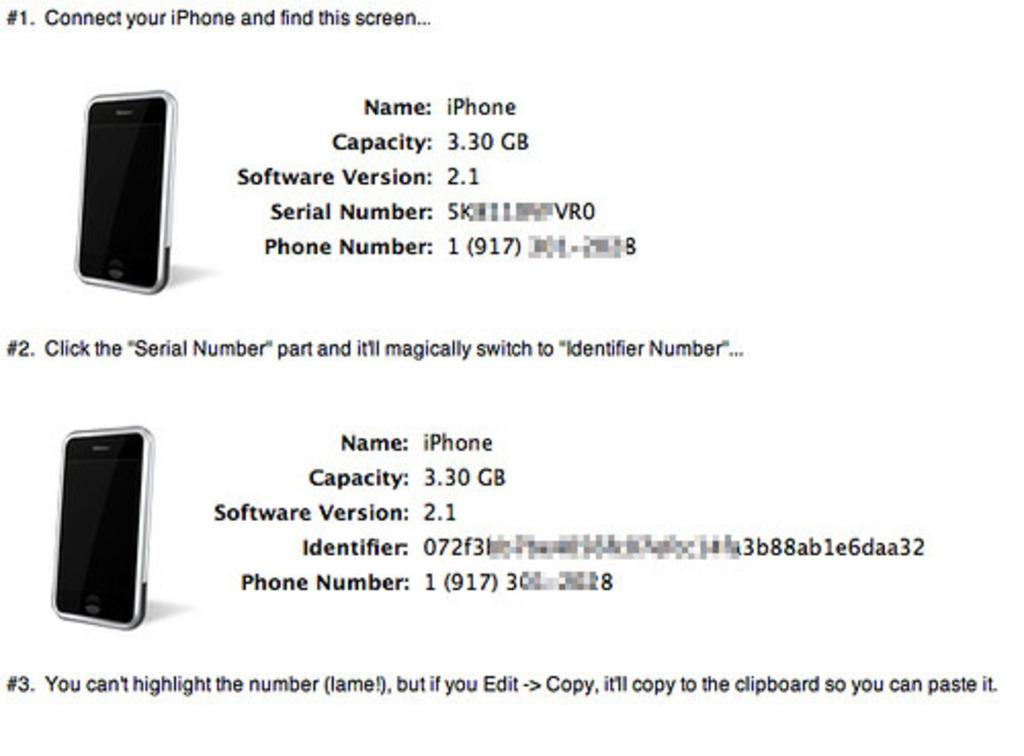Provide a one-sentence caption for the provided image. A screen displaying iphones with capacities of 3.30 gigabytes. 